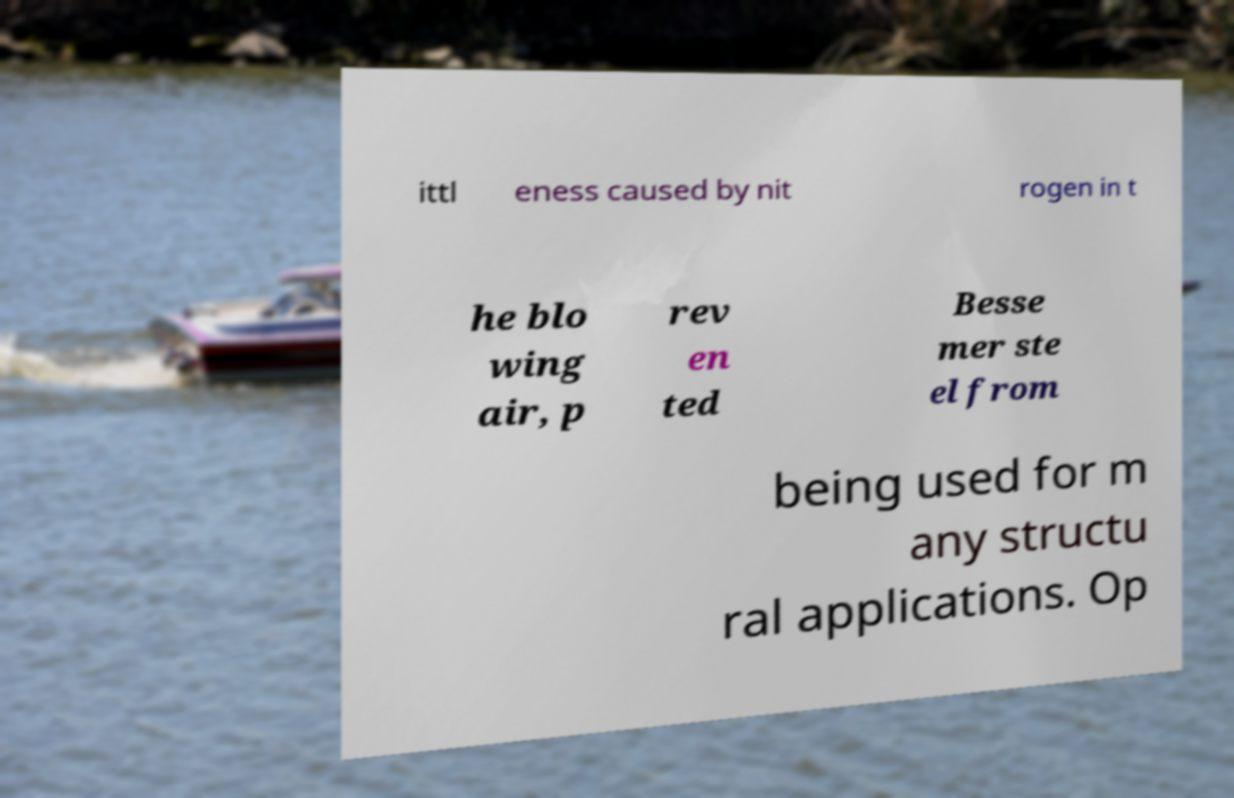Can you read and provide the text displayed in the image?This photo seems to have some interesting text. Can you extract and type it out for me? ittl eness caused by nit rogen in t he blo wing air, p rev en ted Besse mer ste el from being used for m any structu ral applications. Op 